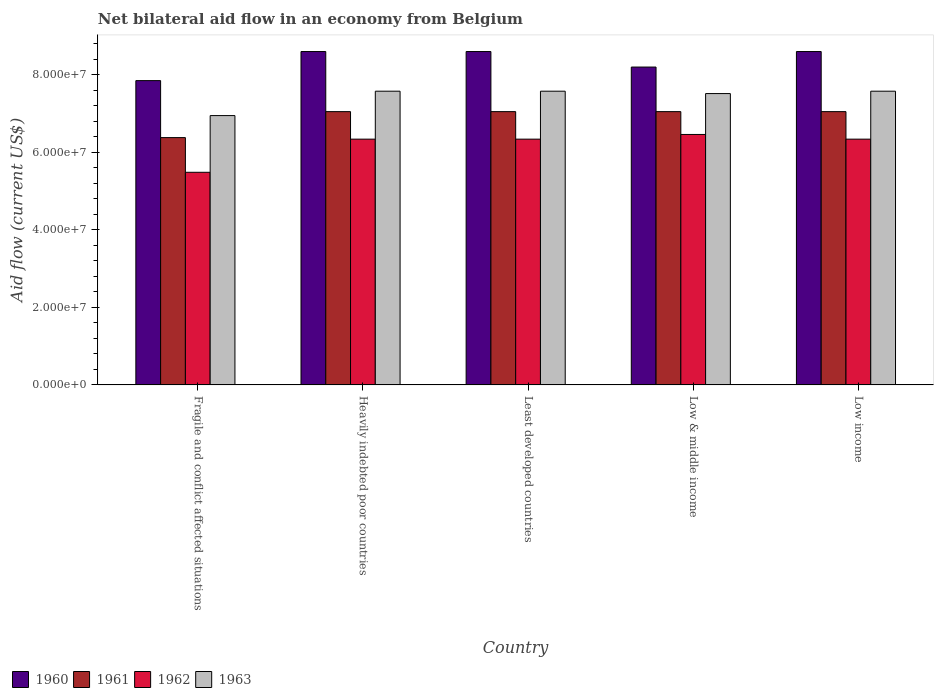How many different coloured bars are there?
Your response must be concise. 4. How many groups of bars are there?
Provide a short and direct response. 5. Are the number of bars on each tick of the X-axis equal?
Your answer should be very brief. Yes. How many bars are there on the 2nd tick from the right?
Offer a very short reply. 4. What is the label of the 1st group of bars from the left?
Your answer should be very brief. Fragile and conflict affected situations. What is the net bilateral aid flow in 1962 in Low income?
Your response must be concise. 6.34e+07. Across all countries, what is the maximum net bilateral aid flow in 1963?
Offer a terse response. 7.58e+07. Across all countries, what is the minimum net bilateral aid flow in 1963?
Make the answer very short. 6.95e+07. In which country was the net bilateral aid flow in 1960 maximum?
Provide a short and direct response. Heavily indebted poor countries. In which country was the net bilateral aid flow in 1961 minimum?
Give a very brief answer. Fragile and conflict affected situations. What is the total net bilateral aid flow in 1963 in the graph?
Ensure brevity in your answer.  3.72e+08. What is the difference between the net bilateral aid flow in 1961 in Heavily indebted poor countries and that in Least developed countries?
Your response must be concise. 0. What is the difference between the net bilateral aid flow in 1960 in Least developed countries and the net bilateral aid flow in 1962 in Low & middle income?
Offer a very short reply. 2.14e+07. What is the average net bilateral aid flow in 1963 per country?
Your answer should be very brief. 7.44e+07. What is the difference between the net bilateral aid flow of/in 1960 and net bilateral aid flow of/in 1963 in Fragile and conflict affected situations?
Your response must be concise. 9.02e+06. In how many countries, is the net bilateral aid flow in 1963 greater than 48000000 US$?
Provide a short and direct response. 5. What is the ratio of the net bilateral aid flow in 1960 in Fragile and conflict affected situations to that in Low income?
Your answer should be compact. 0.91. Is the net bilateral aid flow in 1960 in Least developed countries less than that in Low income?
Your response must be concise. No. Is the difference between the net bilateral aid flow in 1960 in Fragile and conflict affected situations and Least developed countries greater than the difference between the net bilateral aid flow in 1963 in Fragile and conflict affected situations and Least developed countries?
Your response must be concise. No. What is the difference between the highest and the second highest net bilateral aid flow in 1962?
Offer a very short reply. 1.21e+06. What is the difference between the highest and the lowest net bilateral aid flow in 1961?
Provide a succinct answer. 6.70e+06. Is the sum of the net bilateral aid flow in 1960 in Fragile and conflict affected situations and Low income greater than the maximum net bilateral aid flow in 1963 across all countries?
Ensure brevity in your answer.  Yes. Is it the case that in every country, the sum of the net bilateral aid flow in 1963 and net bilateral aid flow in 1962 is greater than the sum of net bilateral aid flow in 1960 and net bilateral aid flow in 1961?
Provide a succinct answer. No. What does the 1st bar from the right in Heavily indebted poor countries represents?
Offer a very short reply. 1963. What is the difference between two consecutive major ticks on the Y-axis?
Offer a terse response. 2.00e+07. Are the values on the major ticks of Y-axis written in scientific E-notation?
Keep it short and to the point. Yes. Does the graph contain grids?
Your response must be concise. No. What is the title of the graph?
Keep it short and to the point. Net bilateral aid flow in an economy from Belgium. What is the label or title of the Y-axis?
Keep it short and to the point. Aid flow (current US$). What is the Aid flow (current US$) of 1960 in Fragile and conflict affected situations?
Keep it short and to the point. 7.85e+07. What is the Aid flow (current US$) in 1961 in Fragile and conflict affected situations?
Your answer should be compact. 6.38e+07. What is the Aid flow (current US$) in 1962 in Fragile and conflict affected situations?
Offer a terse response. 5.48e+07. What is the Aid flow (current US$) of 1963 in Fragile and conflict affected situations?
Your answer should be compact. 6.95e+07. What is the Aid flow (current US$) in 1960 in Heavily indebted poor countries?
Your response must be concise. 8.60e+07. What is the Aid flow (current US$) of 1961 in Heavily indebted poor countries?
Your response must be concise. 7.05e+07. What is the Aid flow (current US$) of 1962 in Heavily indebted poor countries?
Ensure brevity in your answer.  6.34e+07. What is the Aid flow (current US$) of 1963 in Heavily indebted poor countries?
Provide a succinct answer. 7.58e+07. What is the Aid flow (current US$) in 1960 in Least developed countries?
Keep it short and to the point. 8.60e+07. What is the Aid flow (current US$) in 1961 in Least developed countries?
Offer a very short reply. 7.05e+07. What is the Aid flow (current US$) in 1962 in Least developed countries?
Offer a terse response. 6.34e+07. What is the Aid flow (current US$) of 1963 in Least developed countries?
Make the answer very short. 7.58e+07. What is the Aid flow (current US$) of 1960 in Low & middle income?
Ensure brevity in your answer.  8.20e+07. What is the Aid flow (current US$) of 1961 in Low & middle income?
Your answer should be compact. 7.05e+07. What is the Aid flow (current US$) of 1962 in Low & middle income?
Your answer should be very brief. 6.46e+07. What is the Aid flow (current US$) of 1963 in Low & middle income?
Provide a succinct answer. 7.52e+07. What is the Aid flow (current US$) of 1960 in Low income?
Keep it short and to the point. 8.60e+07. What is the Aid flow (current US$) in 1961 in Low income?
Provide a short and direct response. 7.05e+07. What is the Aid flow (current US$) of 1962 in Low income?
Keep it short and to the point. 6.34e+07. What is the Aid flow (current US$) in 1963 in Low income?
Ensure brevity in your answer.  7.58e+07. Across all countries, what is the maximum Aid flow (current US$) in 1960?
Provide a succinct answer. 8.60e+07. Across all countries, what is the maximum Aid flow (current US$) of 1961?
Provide a succinct answer. 7.05e+07. Across all countries, what is the maximum Aid flow (current US$) in 1962?
Offer a terse response. 6.46e+07. Across all countries, what is the maximum Aid flow (current US$) in 1963?
Provide a succinct answer. 7.58e+07. Across all countries, what is the minimum Aid flow (current US$) of 1960?
Ensure brevity in your answer.  7.85e+07. Across all countries, what is the minimum Aid flow (current US$) of 1961?
Offer a terse response. 6.38e+07. Across all countries, what is the minimum Aid flow (current US$) in 1962?
Your response must be concise. 5.48e+07. Across all countries, what is the minimum Aid flow (current US$) in 1963?
Your response must be concise. 6.95e+07. What is the total Aid flow (current US$) in 1960 in the graph?
Provide a short and direct response. 4.18e+08. What is the total Aid flow (current US$) of 1961 in the graph?
Ensure brevity in your answer.  3.46e+08. What is the total Aid flow (current US$) in 1962 in the graph?
Offer a very short reply. 3.10e+08. What is the total Aid flow (current US$) in 1963 in the graph?
Provide a short and direct response. 3.72e+08. What is the difference between the Aid flow (current US$) of 1960 in Fragile and conflict affected situations and that in Heavily indebted poor countries?
Keep it short and to the point. -7.50e+06. What is the difference between the Aid flow (current US$) in 1961 in Fragile and conflict affected situations and that in Heavily indebted poor countries?
Ensure brevity in your answer.  -6.70e+06. What is the difference between the Aid flow (current US$) of 1962 in Fragile and conflict affected situations and that in Heavily indebted poor countries?
Your answer should be very brief. -8.55e+06. What is the difference between the Aid flow (current US$) in 1963 in Fragile and conflict affected situations and that in Heavily indebted poor countries?
Keep it short and to the point. -6.29e+06. What is the difference between the Aid flow (current US$) of 1960 in Fragile and conflict affected situations and that in Least developed countries?
Ensure brevity in your answer.  -7.50e+06. What is the difference between the Aid flow (current US$) of 1961 in Fragile and conflict affected situations and that in Least developed countries?
Provide a short and direct response. -6.70e+06. What is the difference between the Aid flow (current US$) in 1962 in Fragile and conflict affected situations and that in Least developed countries?
Your answer should be compact. -8.55e+06. What is the difference between the Aid flow (current US$) in 1963 in Fragile and conflict affected situations and that in Least developed countries?
Give a very brief answer. -6.29e+06. What is the difference between the Aid flow (current US$) of 1960 in Fragile and conflict affected situations and that in Low & middle income?
Your answer should be very brief. -3.50e+06. What is the difference between the Aid flow (current US$) of 1961 in Fragile and conflict affected situations and that in Low & middle income?
Offer a very short reply. -6.70e+06. What is the difference between the Aid flow (current US$) in 1962 in Fragile and conflict affected situations and that in Low & middle income?
Make the answer very short. -9.76e+06. What is the difference between the Aid flow (current US$) of 1963 in Fragile and conflict affected situations and that in Low & middle income?
Your answer should be compact. -5.68e+06. What is the difference between the Aid flow (current US$) of 1960 in Fragile and conflict affected situations and that in Low income?
Provide a succinct answer. -7.50e+06. What is the difference between the Aid flow (current US$) in 1961 in Fragile and conflict affected situations and that in Low income?
Keep it short and to the point. -6.70e+06. What is the difference between the Aid flow (current US$) in 1962 in Fragile and conflict affected situations and that in Low income?
Make the answer very short. -8.55e+06. What is the difference between the Aid flow (current US$) of 1963 in Fragile and conflict affected situations and that in Low income?
Keep it short and to the point. -6.29e+06. What is the difference between the Aid flow (current US$) of 1961 in Heavily indebted poor countries and that in Least developed countries?
Offer a very short reply. 0. What is the difference between the Aid flow (current US$) of 1960 in Heavily indebted poor countries and that in Low & middle income?
Offer a very short reply. 4.00e+06. What is the difference between the Aid flow (current US$) in 1962 in Heavily indebted poor countries and that in Low & middle income?
Offer a terse response. -1.21e+06. What is the difference between the Aid flow (current US$) of 1963 in Heavily indebted poor countries and that in Low & middle income?
Offer a very short reply. 6.10e+05. What is the difference between the Aid flow (current US$) of 1960 in Heavily indebted poor countries and that in Low income?
Ensure brevity in your answer.  0. What is the difference between the Aid flow (current US$) in 1962 in Heavily indebted poor countries and that in Low income?
Your answer should be very brief. 0. What is the difference between the Aid flow (current US$) of 1963 in Heavily indebted poor countries and that in Low income?
Ensure brevity in your answer.  0. What is the difference between the Aid flow (current US$) of 1962 in Least developed countries and that in Low & middle income?
Provide a short and direct response. -1.21e+06. What is the difference between the Aid flow (current US$) in 1963 in Least developed countries and that in Low & middle income?
Your answer should be very brief. 6.10e+05. What is the difference between the Aid flow (current US$) of 1961 in Least developed countries and that in Low income?
Keep it short and to the point. 0. What is the difference between the Aid flow (current US$) of 1961 in Low & middle income and that in Low income?
Ensure brevity in your answer.  0. What is the difference between the Aid flow (current US$) in 1962 in Low & middle income and that in Low income?
Make the answer very short. 1.21e+06. What is the difference between the Aid flow (current US$) in 1963 in Low & middle income and that in Low income?
Offer a terse response. -6.10e+05. What is the difference between the Aid flow (current US$) in 1960 in Fragile and conflict affected situations and the Aid flow (current US$) in 1961 in Heavily indebted poor countries?
Your answer should be very brief. 8.00e+06. What is the difference between the Aid flow (current US$) of 1960 in Fragile and conflict affected situations and the Aid flow (current US$) of 1962 in Heavily indebted poor countries?
Offer a terse response. 1.51e+07. What is the difference between the Aid flow (current US$) of 1960 in Fragile and conflict affected situations and the Aid flow (current US$) of 1963 in Heavily indebted poor countries?
Your response must be concise. 2.73e+06. What is the difference between the Aid flow (current US$) in 1961 in Fragile and conflict affected situations and the Aid flow (current US$) in 1963 in Heavily indebted poor countries?
Give a very brief answer. -1.20e+07. What is the difference between the Aid flow (current US$) in 1962 in Fragile and conflict affected situations and the Aid flow (current US$) in 1963 in Heavily indebted poor countries?
Provide a short and direct response. -2.09e+07. What is the difference between the Aid flow (current US$) in 1960 in Fragile and conflict affected situations and the Aid flow (current US$) in 1962 in Least developed countries?
Your response must be concise. 1.51e+07. What is the difference between the Aid flow (current US$) of 1960 in Fragile and conflict affected situations and the Aid flow (current US$) of 1963 in Least developed countries?
Your answer should be very brief. 2.73e+06. What is the difference between the Aid flow (current US$) in 1961 in Fragile and conflict affected situations and the Aid flow (current US$) in 1962 in Least developed countries?
Give a very brief answer. 4.00e+05. What is the difference between the Aid flow (current US$) of 1961 in Fragile and conflict affected situations and the Aid flow (current US$) of 1963 in Least developed countries?
Your answer should be very brief. -1.20e+07. What is the difference between the Aid flow (current US$) in 1962 in Fragile and conflict affected situations and the Aid flow (current US$) in 1963 in Least developed countries?
Give a very brief answer. -2.09e+07. What is the difference between the Aid flow (current US$) of 1960 in Fragile and conflict affected situations and the Aid flow (current US$) of 1961 in Low & middle income?
Make the answer very short. 8.00e+06. What is the difference between the Aid flow (current US$) in 1960 in Fragile and conflict affected situations and the Aid flow (current US$) in 1962 in Low & middle income?
Your answer should be very brief. 1.39e+07. What is the difference between the Aid flow (current US$) in 1960 in Fragile and conflict affected situations and the Aid flow (current US$) in 1963 in Low & middle income?
Your response must be concise. 3.34e+06. What is the difference between the Aid flow (current US$) of 1961 in Fragile and conflict affected situations and the Aid flow (current US$) of 1962 in Low & middle income?
Provide a short and direct response. -8.10e+05. What is the difference between the Aid flow (current US$) of 1961 in Fragile and conflict affected situations and the Aid flow (current US$) of 1963 in Low & middle income?
Provide a short and direct response. -1.14e+07. What is the difference between the Aid flow (current US$) in 1962 in Fragile and conflict affected situations and the Aid flow (current US$) in 1963 in Low & middle income?
Keep it short and to the point. -2.03e+07. What is the difference between the Aid flow (current US$) in 1960 in Fragile and conflict affected situations and the Aid flow (current US$) in 1961 in Low income?
Give a very brief answer. 8.00e+06. What is the difference between the Aid flow (current US$) in 1960 in Fragile and conflict affected situations and the Aid flow (current US$) in 1962 in Low income?
Ensure brevity in your answer.  1.51e+07. What is the difference between the Aid flow (current US$) in 1960 in Fragile and conflict affected situations and the Aid flow (current US$) in 1963 in Low income?
Provide a succinct answer. 2.73e+06. What is the difference between the Aid flow (current US$) of 1961 in Fragile and conflict affected situations and the Aid flow (current US$) of 1962 in Low income?
Ensure brevity in your answer.  4.00e+05. What is the difference between the Aid flow (current US$) of 1961 in Fragile and conflict affected situations and the Aid flow (current US$) of 1963 in Low income?
Your answer should be very brief. -1.20e+07. What is the difference between the Aid flow (current US$) in 1962 in Fragile and conflict affected situations and the Aid flow (current US$) in 1963 in Low income?
Your answer should be very brief. -2.09e+07. What is the difference between the Aid flow (current US$) of 1960 in Heavily indebted poor countries and the Aid flow (current US$) of 1961 in Least developed countries?
Offer a very short reply. 1.55e+07. What is the difference between the Aid flow (current US$) in 1960 in Heavily indebted poor countries and the Aid flow (current US$) in 1962 in Least developed countries?
Your answer should be compact. 2.26e+07. What is the difference between the Aid flow (current US$) in 1960 in Heavily indebted poor countries and the Aid flow (current US$) in 1963 in Least developed countries?
Your answer should be compact. 1.02e+07. What is the difference between the Aid flow (current US$) of 1961 in Heavily indebted poor countries and the Aid flow (current US$) of 1962 in Least developed countries?
Offer a terse response. 7.10e+06. What is the difference between the Aid flow (current US$) of 1961 in Heavily indebted poor countries and the Aid flow (current US$) of 1963 in Least developed countries?
Ensure brevity in your answer.  -5.27e+06. What is the difference between the Aid flow (current US$) in 1962 in Heavily indebted poor countries and the Aid flow (current US$) in 1963 in Least developed countries?
Offer a terse response. -1.24e+07. What is the difference between the Aid flow (current US$) in 1960 in Heavily indebted poor countries and the Aid flow (current US$) in 1961 in Low & middle income?
Keep it short and to the point. 1.55e+07. What is the difference between the Aid flow (current US$) in 1960 in Heavily indebted poor countries and the Aid flow (current US$) in 1962 in Low & middle income?
Your answer should be very brief. 2.14e+07. What is the difference between the Aid flow (current US$) of 1960 in Heavily indebted poor countries and the Aid flow (current US$) of 1963 in Low & middle income?
Your answer should be compact. 1.08e+07. What is the difference between the Aid flow (current US$) in 1961 in Heavily indebted poor countries and the Aid flow (current US$) in 1962 in Low & middle income?
Offer a terse response. 5.89e+06. What is the difference between the Aid flow (current US$) of 1961 in Heavily indebted poor countries and the Aid flow (current US$) of 1963 in Low & middle income?
Make the answer very short. -4.66e+06. What is the difference between the Aid flow (current US$) of 1962 in Heavily indebted poor countries and the Aid flow (current US$) of 1963 in Low & middle income?
Offer a terse response. -1.18e+07. What is the difference between the Aid flow (current US$) in 1960 in Heavily indebted poor countries and the Aid flow (current US$) in 1961 in Low income?
Your answer should be very brief. 1.55e+07. What is the difference between the Aid flow (current US$) of 1960 in Heavily indebted poor countries and the Aid flow (current US$) of 1962 in Low income?
Your response must be concise. 2.26e+07. What is the difference between the Aid flow (current US$) in 1960 in Heavily indebted poor countries and the Aid flow (current US$) in 1963 in Low income?
Your answer should be compact. 1.02e+07. What is the difference between the Aid flow (current US$) in 1961 in Heavily indebted poor countries and the Aid flow (current US$) in 1962 in Low income?
Offer a very short reply. 7.10e+06. What is the difference between the Aid flow (current US$) in 1961 in Heavily indebted poor countries and the Aid flow (current US$) in 1963 in Low income?
Ensure brevity in your answer.  -5.27e+06. What is the difference between the Aid flow (current US$) of 1962 in Heavily indebted poor countries and the Aid flow (current US$) of 1963 in Low income?
Your answer should be compact. -1.24e+07. What is the difference between the Aid flow (current US$) in 1960 in Least developed countries and the Aid flow (current US$) in 1961 in Low & middle income?
Give a very brief answer. 1.55e+07. What is the difference between the Aid flow (current US$) of 1960 in Least developed countries and the Aid flow (current US$) of 1962 in Low & middle income?
Your answer should be compact. 2.14e+07. What is the difference between the Aid flow (current US$) of 1960 in Least developed countries and the Aid flow (current US$) of 1963 in Low & middle income?
Your answer should be compact. 1.08e+07. What is the difference between the Aid flow (current US$) of 1961 in Least developed countries and the Aid flow (current US$) of 1962 in Low & middle income?
Keep it short and to the point. 5.89e+06. What is the difference between the Aid flow (current US$) in 1961 in Least developed countries and the Aid flow (current US$) in 1963 in Low & middle income?
Give a very brief answer. -4.66e+06. What is the difference between the Aid flow (current US$) of 1962 in Least developed countries and the Aid flow (current US$) of 1963 in Low & middle income?
Offer a very short reply. -1.18e+07. What is the difference between the Aid flow (current US$) in 1960 in Least developed countries and the Aid flow (current US$) in 1961 in Low income?
Your answer should be very brief. 1.55e+07. What is the difference between the Aid flow (current US$) of 1960 in Least developed countries and the Aid flow (current US$) of 1962 in Low income?
Your answer should be very brief. 2.26e+07. What is the difference between the Aid flow (current US$) of 1960 in Least developed countries and the Aid flow (current US$) of 1963 in Low income?
Provide a short and direct response. 1.02e+07. What is the difference between the Aid flow (current US$) of 1961 in Least developed countries and the Aid flow (current US$) of 1962 in Low income?
Your answer should be very brief. 7.10e+06. What is the difference between the Aid flow (current US$) in 1961 in Least developed countries and the Aid flow (current US$) in 1963 in Low income?
Keep it short and to the point. -5.27e+06. What is the difference between the Aid flow (current US$) in 1962 in Least developed countries and the Aid flow (current US$) in 1963 in Low income?
Your answer should be very brief. -1.24e+07. What is the difference between the Aid flow (current US$) in 1960 in Low & middle income and the Aid flow (current US$) in 1961 in Low income?
Provide a short and direct response. 1.15e+07. What is the difference between the Aid flow (current US$) of 1960 in Low & middle income and the Aid flow (current US$) of 1962 in Low income?
Ensure brevity in your answer.  1.86e+07. What is the difference between the Aid flow (current US$) in 1960 in Low & middle income and the Aid flow (current US$) in 1963 in Low income?
Keep it short and to the point. 6.23e+06. What is the difference between the Aid flow (current US$) in 1961 in Low & middle income and the Aid flow (current US$) in 1962 in Low income?
Offer a very short reply. 7.10e+06. What is the difference between the Aid flow (current US$) in 1961 in Low & middle income and the Aid flow (current US$) in 1963 in Low income?
Give a very brief answer. -5.27e+06. What is the difference between the Aid flow (current US$) of 1962 in Low & middle income and the Aid flow (current US$) of 1963 in Low income?
Your answer should be very brief. -1.12e+07. What is the average Aid flow (current US$) in 1960 per country?
Provide a short and direct response. 8.37e+07. What is the average Aid flow (current US$) in 1961 per country?
Your answer should be very brief. 6.92e+07. What is the average Aid flow (current US$) in 1962 per country?
Make the answer very short. 6.19e+07. What is the average Aid flow (current US$) in 1963 per country?
Offer a very short reply. 7.44e+07. What is the difference between the Aid flow (current US$) in 1960 and Aid flow (current US$) in 1961 in Fragile and conflict affected situations?
Your answer should be compact. 1.47e+07. What is the difference between the Aid flow (current US$) in 1960 and Aid flow (current US$) in 1962 in Fragile and conflict affected situations?
Keep it short and to the point. 2.36e+07. What is the difference between the Aid flow (current US$) in 1960 and Aid flow (current US$) in 1963 in Fragile and conflict affected situations?
Ensure brevity in your answer.  9.02e+06. What is the difference between the Aid flow (current US$) in 1961 and Aid flow (current US$) in 1962 in Fragile and conflict affected situations?
Give a very brief answer. 8.95e+06. What is the difference between the Aid flow (current US$) of 1961 and Aid flow (current US$) of 1963 in Fragile and conflict affected situations?
Make the answer very short. -5.68e+06. What is the difference between the Aid flow (current US$) of 1962 and Aid flow (current US$) of 1963 in Fragile and conflict affected situations?
Provide a short and direct response. -1.46e+07. What is the difference between the Aid flow (current US$) in 1960 and Aid flow (current US$) in 1961 in Heavily indebted poor countries?
Your response must be concise. 1.55e+07. What is the difference between the Aid flow (current US$) of 1960 and Aid flow (current US$) of 1962 in Heavily indebted poor countries?
Offer a terse response. 2.26e+07. What is the difference between the Aid flow (current US$) of 1960 and Aid flow (current US$) of 1963 in Heavily indebted poor countries?
Give a very brief answer. 1.02e+07. What is the difference between the Aid flow (current US$) of 1961 and Aid flow (current US$) of 1962 in Heavily indebted poor countries?
Your response must be concise. 7.10e+06. What is the difference between the Aid flow (current US$) in 1961 and Aid flow (current US$) in 1963 in Heavily indebted poor countries?
Ensure brevity in your answer.  -5.27e+06. What is the difference between the Aid flow (current US$) in 1962 and Aid flow (current US$) in 1963 in Heavily indebted poor countries?
Provide a succinct answer. -1.24e+07. What is the difference between the Aid flow (current US$) of 1960 and Aid flow (current US$) of 1961 in Least developed countries?
Keep it short and to the point. 1.55e+07. What is the difference between the Aid flow (current US$) of 1960 and Aid flow (current US$) of 1962 in Least developed countries?
Offer a terse response. 2.26e+07. What is the difference between the Aid flow (current US$) of 1960 and Aid flow (current US$) of 1963 in Least developed countries?
Give a very brief answer. 1.02e+07. What is the difference between the Aid flow (current US$) of 1961 and Aid flow (current US$) of 1962 in Least developed countries?
Your answer should be very brief. 7.10e+06. What is the difference between the Aid flow (current US$) of 1961 and Aid flow (current US$) of 1963 in Least developed countries?
Keep it short and to the point. -5.27e+06. What is the difference between the Aid flow (current US$) of 1962 and Aid flow (current US$) of 1963 in Least developed countries?
Make the answer very short. -1.24e+07. What is the difference between the Aid flow (current US$) in 1960 and Aid flow (current US$) in 1961 in Low & middle income?
Make the answer very short. 1.15e+07. What is the difference between the Aid flow (current US$) in 1960 and Aid flow (current US$) in 1962 in Low & middle income?
Provide a succinct answer. 1.74e+07. What is the difference between the Aid flow (current US$) of 1960 and Aid flow (current US$) of 1963 in Low & middle income?
Your answer should be very brief. 6.84e+06. What is the difference between the Aid flow (current US$) of 1961 and Aid flow (current US$) of 1962 in Low & middle income?
Make the answer very short. 5.89e+06. What is the difference between the Aid flow (current US$) of 1961 and Aid flow (current US$) of 1963 in Low & middle income?
Your answer should be very brief. -4.66e+06. What is the difference between the Aid flow (current US$) of 1962 and Aid flow (current US$) of 1963 in Low & middle income?
Offer a very short reply. -1.06e+07. What is the difference between the Aid flow (current US$) in 1960 and Aid flow (current US$) in 1961 in Low income?
Your answer should be compact. 1.55e+07. What is the difference between the Aid flow (current US$) in 1960 and Aid flow (current US$) in 1962 in Low income?
Keep it short and to the point. 2.26e+07. What is the difference between the Aid flow (current US$) of 1960 and Aid flow (current US$) of 1963 in Low income?
Provide a short and direct response. 1.02e+07. What is the difference between the Aid flow (current US$) of 1961 and Aid flow (current US$) of 1962 in Low income?
Your response must be concise. 7.10e+06. What is the difference between the Aid flow (current US$) in 1961 and Aid flow (current US$) in 1963 in Low income?
Ensure brevity in your answer.  -5.27e+06. What is the difference between the Aid flow (current US$) of 1962 and Aid flow (current US$) of 1963 in Low income?
Offer a very short reply. -1.24e+07. What is the ratio of the Aid flow (current US$) of 1960 in Fragile and conflict affected situations to that in Heavily indebted poor countries?
Ensure brevity in your answer.  0.91. What is the ratio of the Aid flow (current US$) of 1961 in Fragile and conflict affected situations to that in Heavily indebted poor countries?
Give a very brief answer. 0.91. What is the ratio of the Aid flow (current US$) in 1962 in Fragile and conflict affected situations to that in Heavily indebted poor countries?
Offer a terse response. 0.87. What is the ratio of the Aid flow (current US$) of 1963 in Fragile and conflict affected situations to that in Heavily indebted poor countries?
Provide a short and direct response. 0.92. What is the ratio of the Aid flow (current US$) of 1960 in Fragile and conflict affected situations to that in Least developed countries?
Provide a succinct answer. 0.91. What is the ratio of the Aid flow (current US$) of 1961 in Fragile and conflict affected situations to that in Least developed countries?
Provide a short and direct response. 0.91. What is the ratio of the Aid flow (current US$) of 1962 in Fragile and conflict affected situations to that in Least developed countries?
Give a very brief answer. 0.87. What is the ratio of the Aid flow (current US$) in 1963 in Fragile and conflict affected situations to that in Least developed countries?
Keep it short and to the point. 0.92. What is the ratio of the Aid flow (current US$) of 1960 in Fragile and conflict affected situations to that in Low & middle income?
Your answer should be very brief. 0.96. What is the ratio of the Aid flow (current US$) in 1961 in Fragile and conflict affected situations to that in Low & middle income?
Ensure brevity in your answer.  0.91. What is the ratio of the Aid flow (current US$) of 1962 in Fragile and conflict affected situations to that in Low & middle income?
Ensure brevity in your answer.  0.85. What is the ratio of the Aid flow (current US$) in 1963 in Fragile and conflict affected situations to that in Low & middle income?
Offer a very short reply. 0.92. What is the ratio of the Aid flow (current US$) in 1960 in Fragile and conflict affected situations to that in Low income?
Ensure brevity in your answer.  0.91. What is the ratio of the Aid flow (current US$) in 1961 in Fragile and conflict affected situations to that in Low income?
Your response must be concise. 0.91. What is the ratio of the Aid flow (current US$) in 1962 in Fragile and conflict affected situations to that in Low income?
Your answer should be very brief. 0.87. What is the ratio of the Aid flow (current US$) of 1963 in Fragile and conflict affected situations to that in Low income?
Offer a very short reply. 0.92. What is the ratio of the Aid flow (current US$) of 1960 in Heavily indebted poor countries to that in Least developed countries?
Your answer should be compact. 1. What is the ratio of the Aid flow (current US$) in 1961 in Heavily indebted poor countries to that in Least developed countries?
Provide a succinct answer. 1. What is the ratio of the Aid flow (current US$) in 1963 in Heavily indebted poor countries to that in Least developed countries?
Make the answer very short. 1. What is the ratio of the Aid flow (current US$) in 1960 in Heavily indebted poor countries to that in Low & middle income?
Provide a succinct answer. 1.05. What is the ratio of the Aid flow (current US$) in 1961 in Heavily indebted poor countries to that in Low & middle income?
Make the answer very short. 1. What is the ratio of the Aid flow (current US$) in 1962 in Heavily indebted poor countries to that in Low & middle income?
Keep it short and to the point. 0.98. What is the ratio of the Aid flow (current US$) in 1963 in Heavily indebted poor countries to that in Low & middle income?
Make the answer very short. 1.01. What is the ratio of the Aid flow (current US$) in 1960 in Heavily indebted poor countries to that in Low income?
Keep it short and to the point. 1. What is the ratio of the Aid flow (current US$) of 1961 in Heavily indebted poor countries to that in Low income?
Keep it short and to the point. 1. What is the ratio of the Aid flow (current US$) of 1960 in Least developed countries to that in Low & middle income?
Your answer should be compact. 1.05. What is the ratio of the Aid flow (current US$) in 1961 in Least developed countries to that in Low & middle income?
Keep it short and to the point. 1. What is the ratio of the Aid flow (current US$) of 1962 in Least developed countries to that in Low & middle income?
Provide a short and direct response. 0.98. What is the ratio of the Aid flow (current US$) in 1963 in Least developed countries to that in Low & middle income?
Your answer should be compact. 1.01. What is the ratio of the Aid flow (current US$) in 1960 in Least developed countries to that in Low income?
Provide a succinct answer. 1. What is the ratio of the Aid flow (current US$) of 1960 in Low & middle income to that in Low income?
Make the answer very short. 0.95. What is the ratio of the Aid flow (current US$) in 1962 in Low & middle income to that in Low income?
Give a very brief answer. 1.02. What is the difference between the highest and the second highest Aid flow (current US$) of 1961?
Offer a very short reply. 0. What is the difference between the highest and the second highest Aid flow (current US$) in 1962?
Offer a terse response. 1.21e+06. What is the difference between the highest and the second highest Aid flow (current US$) in 1963?
Offer a very short reply. 0. What is the difference between the highest and the lowest Aid flow (current US$) of 1960?
Provide a succinct answer. 7.50e+06. What is the difference between the highest and the lowest Aid flow (current US$) of 1961?
Offer a very short reply. 6.70e+06. What is the difference between the highest and the lowest Aid flow (current US$) of 1962?
Make the answer very short. 9.76e+06. What is the difference between the highest and the lowest Aid flow (current US$) in 1963?
Your answer should be very brief. 6.29e+06. 